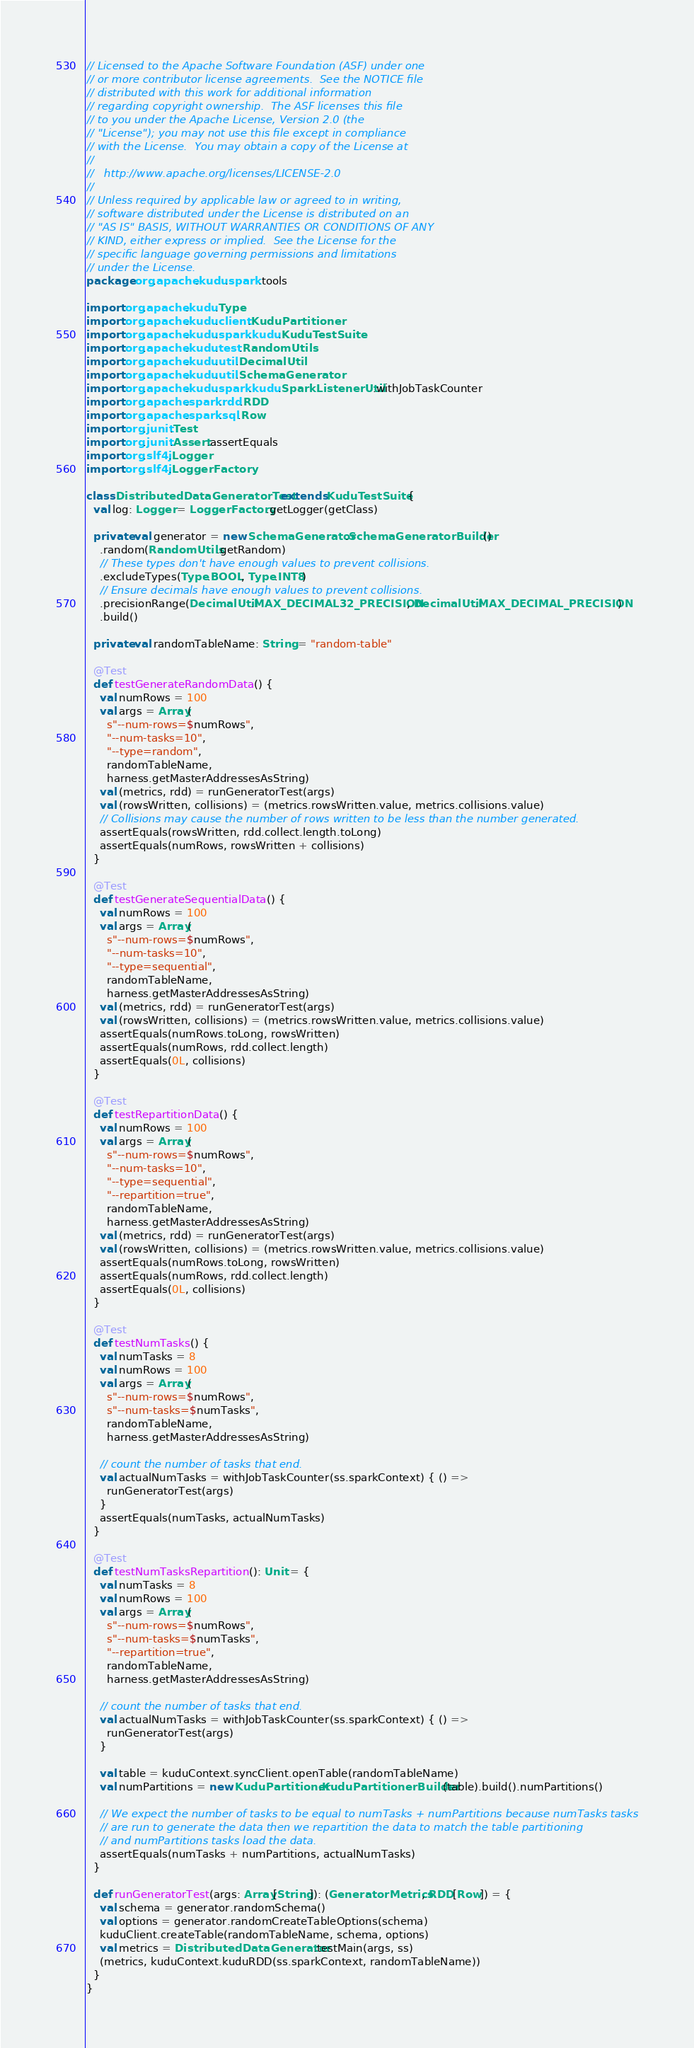Convert code to text. <code><loc_0><loc_0><loc_500><loc_500><_Scala_>// Licensed to the Apache Software Foundation (ASF) under one
// or more contributor license agreements.  See the NOTICE file
// distributed with this work for additional information
// regarding copyright ownership.  The ASF licenses this file
// to you under the Apache License, Version 2.0 (the
// "License"); you may not use this file except in compliance
// with the License.  You may obtain a copy of the License at
//
//   http://www.apache.org/licenses/LICENSE-2.0
//
// Unless required by applicable law or agreed to in writing,
// software distributed under the License is distributed on an
// "AS IS" BASIS, WITHOUT WARRANTIES OR CONDITIONS OF ANY
// KIND, either express or implied.  See the License for the
// specific language governing permissions and limitations
// under the License.
package org.apache.kudu.spark.tools

import org.apache.kudu.Type
import org.apache.kudu.client.KuduPartitioner
import org.apache.kudu.spark.kudu.KuduTestSuite
import org.apache.kudu.test.RandomUtils
import org.apache.kudu.util.DecimalUtil
import org.apache.kudu.util.SchemaGenerator
import org.apache.kudu.spark.kudu.SparkListenerUtil.withJobTaskCounter
import org.apache.spark.rdd.RDD
import org.apache.spark.sql.Row
import org.junit.Test
import org.junit.Assert.assertEquals
import org.slf4j.Logger
import org.slf4j.LoggerFactory

class DistributedDataGeneratorTest extends KuduTestSuite {
  val log: Logger = LoggerFactory.getLogger(getClass)

  private val generator = new SchemaGenerator.SchemaGeneratorBuilder()
    .random(RandomUtils.getRandom)
    // These types don't have enough values to prevent collisions.
    .excludeTypes(Type.BOOL, Type.INT8)
    // Ensure decimals have enough values to prevent collisions.
    .precisionRange(DecimalUtil.MAX_DECIMAL32_PRECISION, DecimalUtil.MAX_DECIMAL_PRECISION)
    .build()

  private val randomTableName: String = "random-table"

  @Test
  def testGenerateRandomData() {
    val numRows = 100
    val args = Array(
      s"--num-rows=$numRows",
      "--num-tasks=10",
      "--type=random",
      randomTableName,
      harness.getMasterAddressesAsString)
    val (metrics, rdd) = runGeneratorTest(args)
    val (rowsWritten, collisions) = (metrics.rowsWritten.value, metrics.collisions.value)
    // Collisions may cause the number of rows written to be less than the number generated.
    assertEquals(rowsWritten, rdd.collect.length.toLong)
    assertEquals(numRows, rowsWritten + collisions)
  }

  @Test
  def testGenerateSequentialData() {
    val numRows = 100
    val args = Array(
      s"--num-rows=$numRows",
      "--num-tasks=10",
      "--type=sequential",
      randomTableName,
      harness.getMasterAddressesAsString)
    val (metrics, rdd) = runGeneratorTest(args)
    val (rowsWritten, collisions) = (metrics.rowsWritten.value, metrics.collisions.value)
    assertEquals(numRows.toLong, rowsWritten)
    assertEquals(numRows, rdd.collect.length)
    assertEquals(0L, collisions)
  }

  @Test
  def testRepartitionData() {
    val numRows = 100
    val args = Array(
      s"--num-rows=$numRows",
      "--num-tasks=10",
      "--type=sequential",
      "--repartition=true",
      randomTableName,
      harness.getMasterAddressesAsString)
    val (metrics, rdd) = runGeneratorTest(args)
    val (rowsWritten, collisions) = (metrics.rowsWritten.value, metrics.collisions.value)
    assertEquals(numRows.toLong, rowsWritten)
    assertEquals(numRows, rdd.collect.length)
    assertEquals(0L, collisions)
  }

  @Test
  def testNumTasks() {
    val numTasks = 8
    val numRows = 100
    val args = Array(
      s"--num-rows=$numRows",
      s"--num-tasks=$numTasks",
      randomTableName,
      harness.getMasterAddressesAsString)

    // count the number of tasks that end.
    val actualNumTasks = withJobTaskCounter(ss.sparkContext) { () =>
      runGeneratorTest(args)
    }
    assertEquals(numTasks, actualNumTasks)
  }

  @Test
  def testNumTasksRepartition(): Unit = {
    val numTasks = 8
    val numRows = 100
    val args = Array(
      s"--num-rows=$numRows",
      s"--num-tasks=$numTasks",
      "--repartition=true",
      randomTableName,
      harness.getMasterAddressesAsString)

    // count the number of tasks that end.
    val actualNumTasks = withJobTaskCounter(ss.sparkContext) { () =>
      runGeneratorTest(args)
    }

    val table = kuduContext.syncClient.openTable(randomTableName)
    val numPartitions = new KuduPartitioner.KuduPartitionerBuilder(table).build().numPartitions()

    // We expect the number of tasks to be equal to numTasks + numPartitions because numTasks tasks
    // are run to generate the data then we repartition the data to match the table partitioning
    // and numPartitions tasks load the data.
    assertEquals(numTasks + numPartitions, actualNumTasks)
  }

  def runGeneratorTest(args: Array[String]): (GeneratorMetrics, RDD[Row]) = {
    val schema = generator.randomSchema()
    val options = generator.randomCreateTableOptions(schema)
    kuduClient.createTable(randomTableName, schema, options)
    val metrics = DistributedDataGenerator.testMain(args, ss)
    (metrics, kuduContext.kuduRDD(ss.sparkContext, randomTableName))
  }
}
</code> 